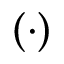<formula> <loc_0><loc_0><loc_500><loc_500>( \cdot )</formula> 